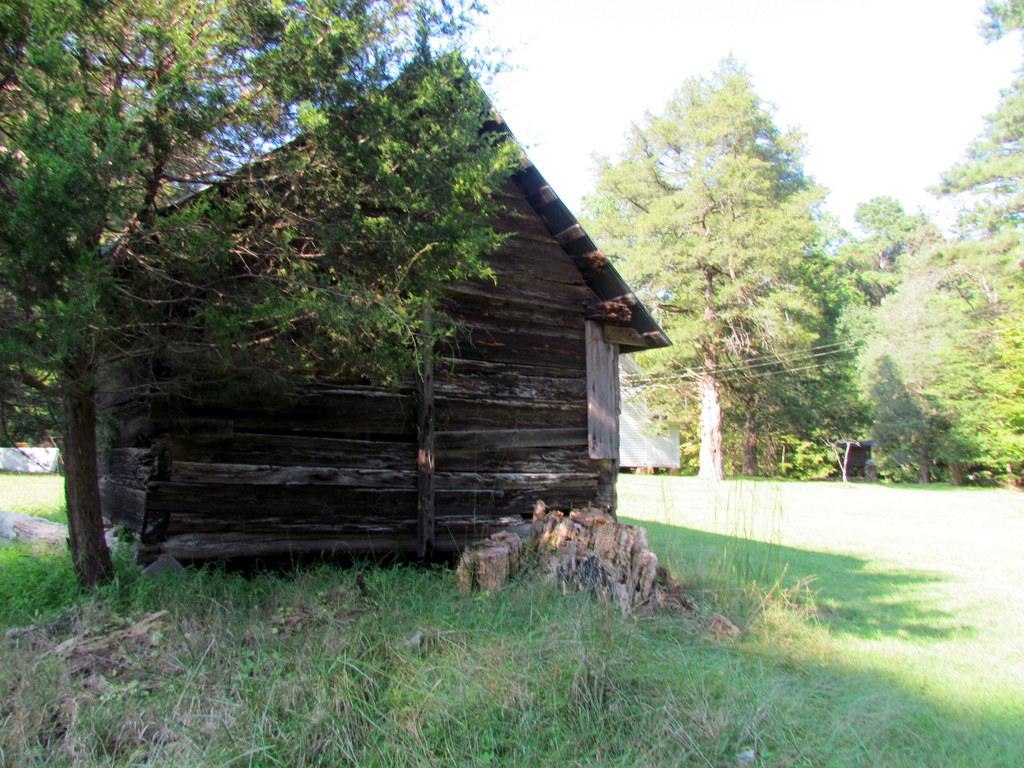What type of vegetation is present in the image? There is grass in the image. What other natural elements can be seen in the image? There are trees in the image. What type of structure is visible in the image? There is a house in the image. What is visible in the background of the image? The sky is visible in the background of the image. Can you tell me how many buttons are on the oatmeal in the image? There is no oatmeal or buttons present in the image. What type of island can be seen in the background of the image? There is no island present in the image; it features grass, trees, a house, and the sky. 